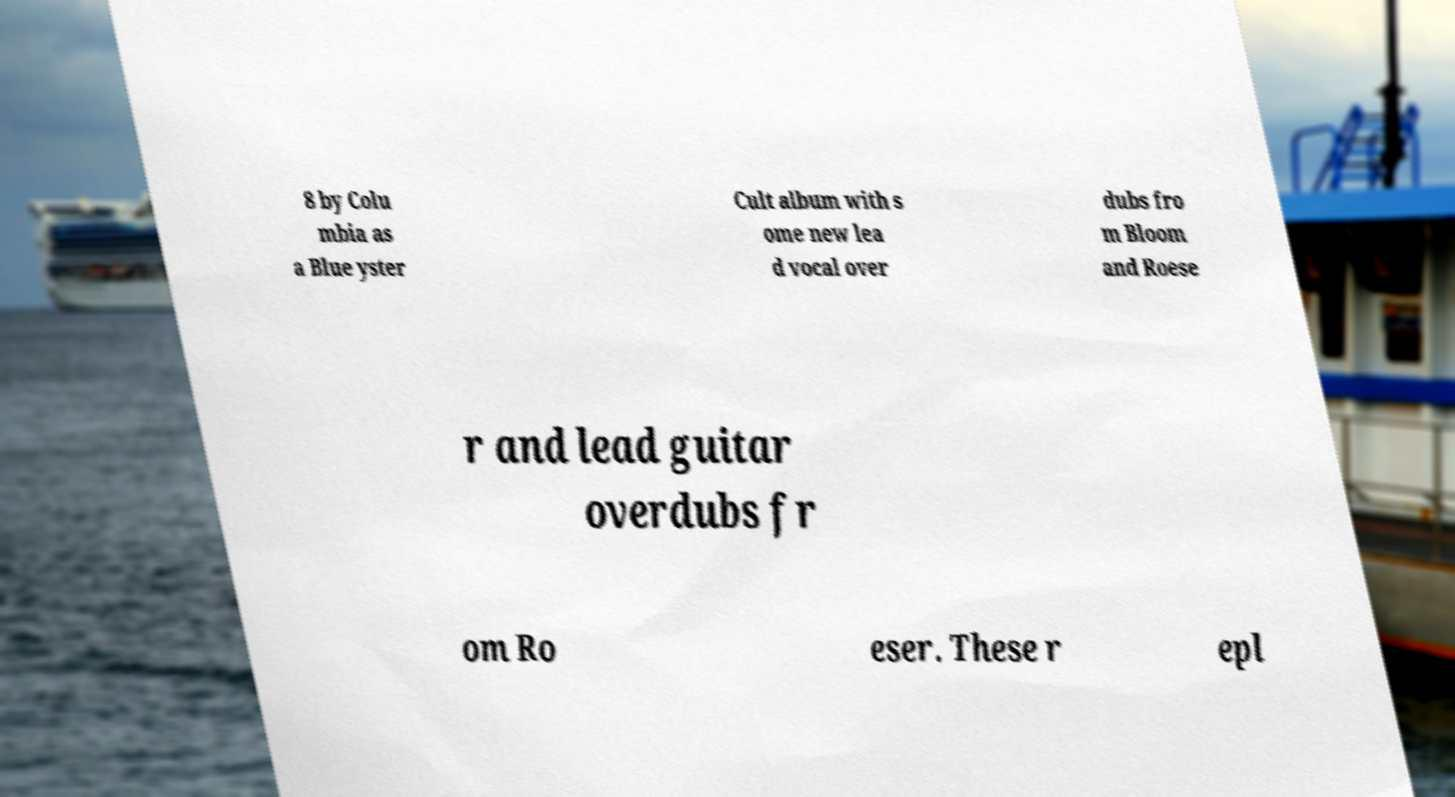For documentation purposes, I need the text within this image transcribed. Could you provide that? 8 by Colu mbia as a Blue yster Cult album with s ome new lea d vocal over dubs fro m Bloom and Roese r and lead guitar overdubs fr om Ro eser. These r epl 